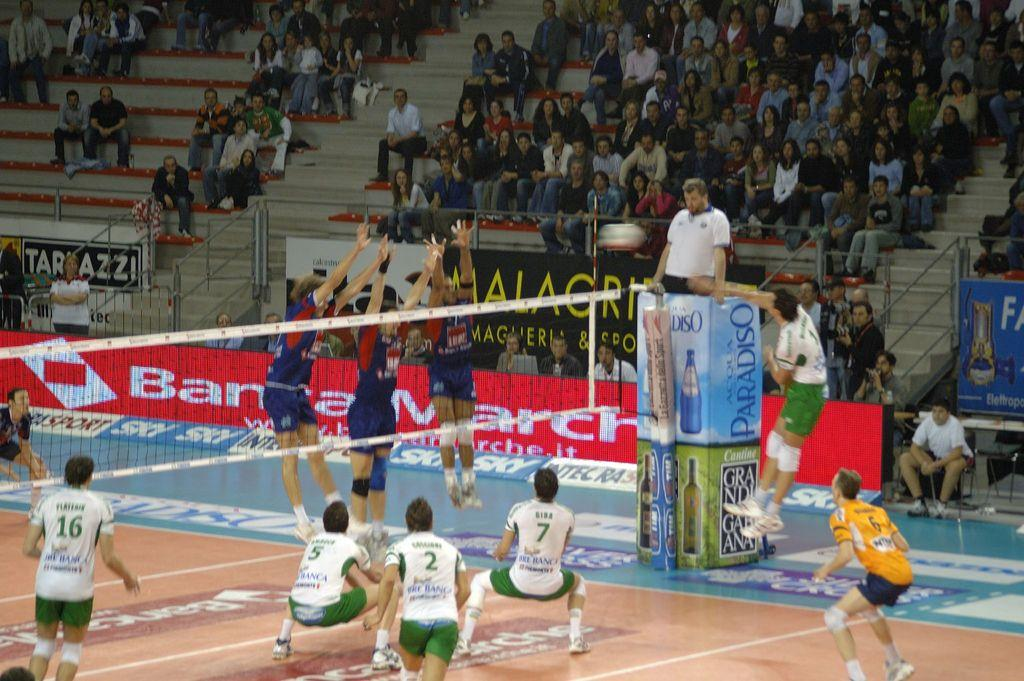<image>
Create a compact narrative representing the image presented. Volleyball players compete near ads for products like Paradiso and Sky. 